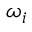<formula> <loc_0><loc_0><loc_500><loc_500>\omega _ { i }</formula> 